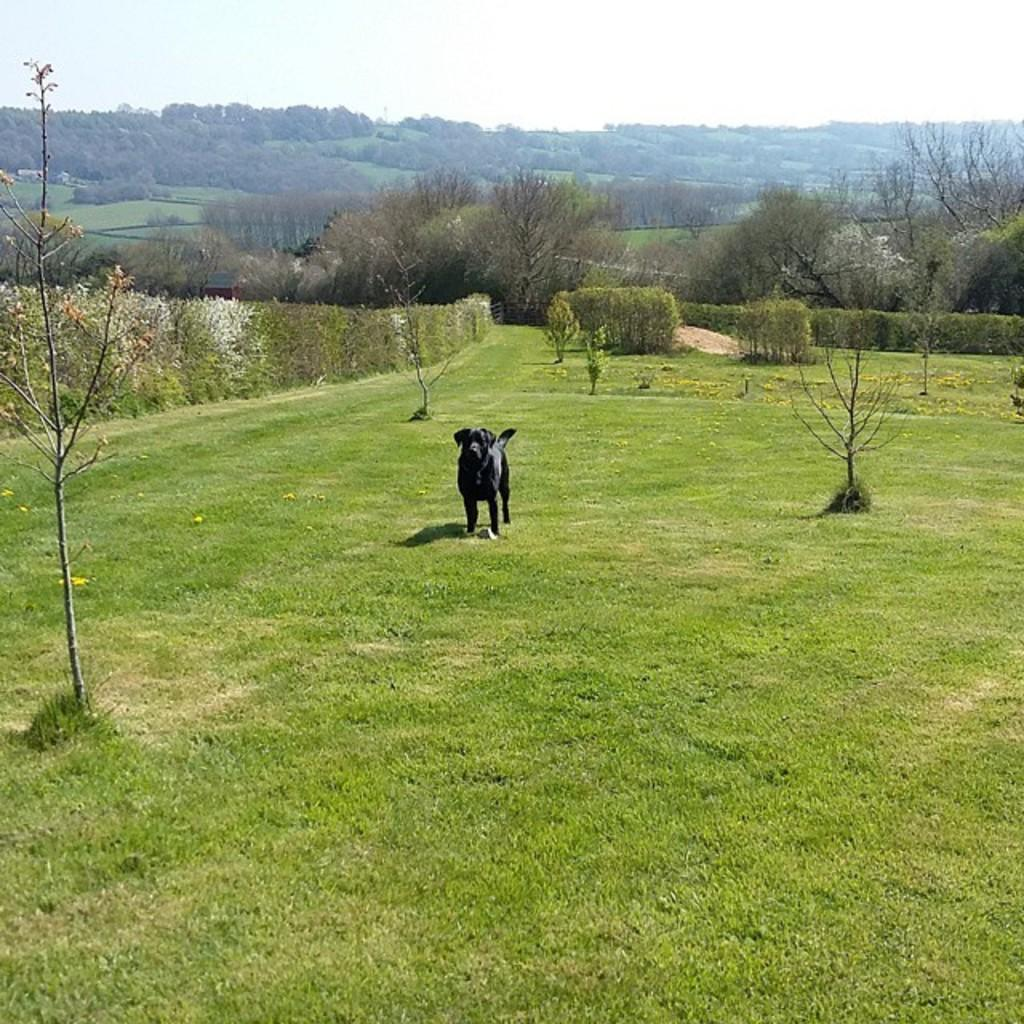What animal is present in the image? There is a dog in the image. Where is the dog located? The dog is on the grass. What can be seen in the background of the image? There are trees in the background of the image. What type of butter is being used to keep the dog cool in the shade? There is no butter or shade present in the image; the dog is on the grass, and there are trees in the background. 